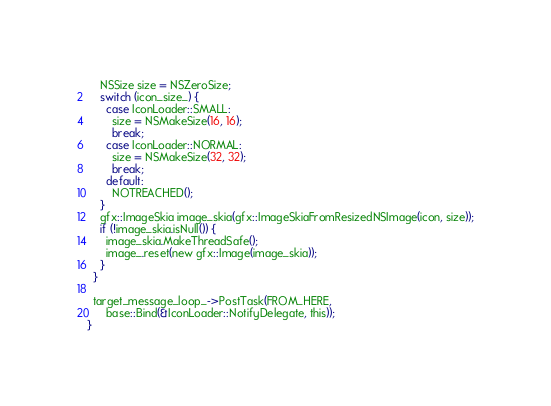<code> <loc_0><loc_0><loc_500><loc_500><_ObjectiveC_>    NSSize size = NSZeroSize;
    switch (icon_size_) {
      case IconLoader::SMALL:
        size = NSMakeSize(16, 16);
        break;
      case IconLoader::NORMAL:
        size = NSMakeSize(32, 32);
        break;
      default:
        NOTREACHED();
    }
    gfx::ImageSkia image_skia(gfx::ImageSkiaFromResizedNSImage(icon, size));
    if (!image_skia.isNull()) {
      image_skia.MakeThreadSafe();
      image_.reset(new gfx::Image(image_skia));
    }
  }

  target_message_loop_->PostTask(FROM_HERE,
      base::Bind(&IconLoader::NotifyDelegate, this));
}
</code> 